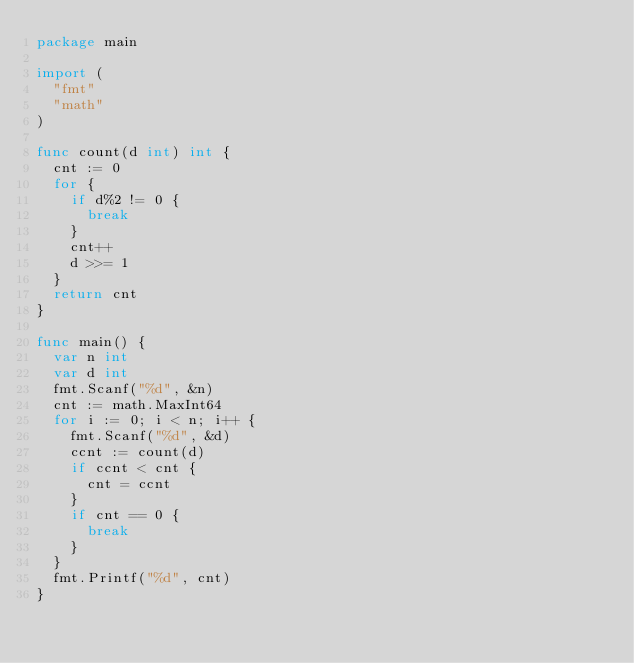Convert code to text. <code><loc_0><loc_0><loc_500><loc_500><_Go_>package main

import (
	"fmt"
	"math"
)

func count(d int) int {
	cnt := 0
	for {
		if d%2 != 0 {
			break
		}
		cnt++
		d >>= 1
	}
	return cnt
}

func main() {
	var n int
	var d int
	fmt.Scanf("%d", &n)
	cnt := math.MaxInt64
	for i := 0; i < n; i++ {
		fmt.Scanf("%d", &d)
		ccnt := count(d)
		if ccnt < cnt {
			cnt = ccnt
		}
		if cnt == 0 {
			break
		}
	}
	fmt.Printf("%d", cnt)
}
</code> 